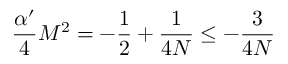<formula> <loc_0><loc_0><loc_500><loc_500>\frac { \alpha ^ { \prime } } 4 M ^ { 2 } = - \frac { 1 } { 2 } + \frac { 1 } 4 N } \leq - \frac { 3 } 4 N }</formula> 